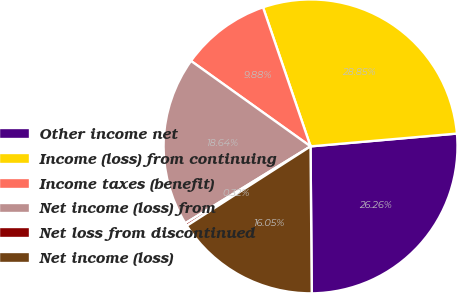Convert chart. <chart><loc_0><loc_0><loc_500><loc_500><pie_chart><fcel>Other income net<fcel>Income (loss) from continuing<fcel>Income taxes (benefit)<fcel>Net income (loss) from<fcel>Net loss from discontinued<fcel>Net income (loss)<nl><fcel>26.26%<fcel>28.85%<fcel>9.88%<fcel>18.64%<fcel>0.32%<fcel>16.05%<nl></chart> 